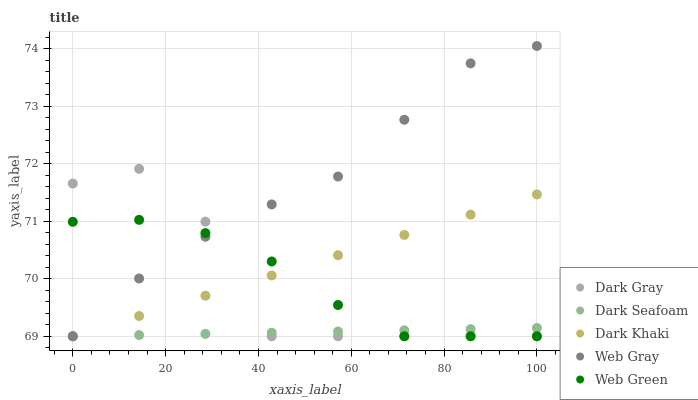Does Dark Seafoam have the minimum area under the curve?
Answer yes or no. Yes. Does Web Gray have the maximum area under the curve?
Answer yes or no. Yes. Does Dark Khaki have the minimum area under the curve?
Answer yes or no. No. Does Dark Khaki have the maximum area under the curve?
Answer yes or no. No. Is Dark Khaki the smoothest?
Answer yes or no. Yes. Is Dark Gray the roughest?
Answer yes or no. Yes. Is Dark Seafoam the smoothest?
Answer yes or no. No. Is Dark Seafoam the roughest?
Answer yes or no. No. Does Dark Gray have the lowest value?
Answer yes or no. Yes. Does Web Gray have the highest value?
Answer yes or no. Yes. Does Dark Khaki have the highest value?
Answer yes or no. No. Does Dark Seafoam intersect Web Gray?
Answer yes or no. Yes. Is Dark Seafoam less than Web Gray?
Answer yes or no. No. Is Dark Seafoam greater than Web Gray?
Answer yes or no. No. 